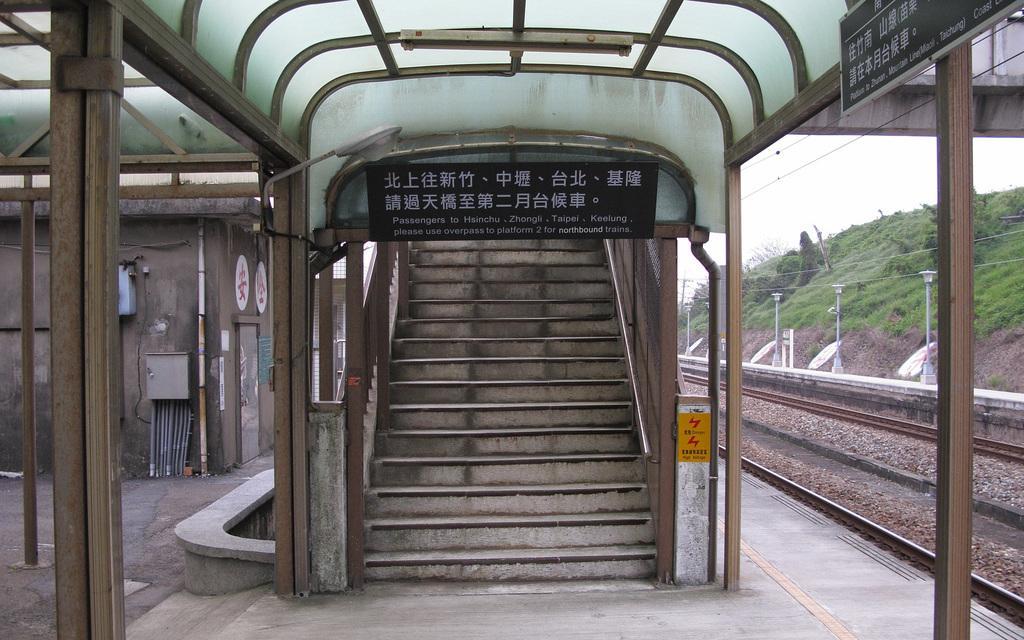Can you describe this image briefly? This image is taken in a railway station. There are stars visible. At the top there is roof for shelter. There is also a black color board with white text. On the left door, wall and pipes are visible. On the right railway track and also poles with wires. Grass, trees and sky are visible in this image. 